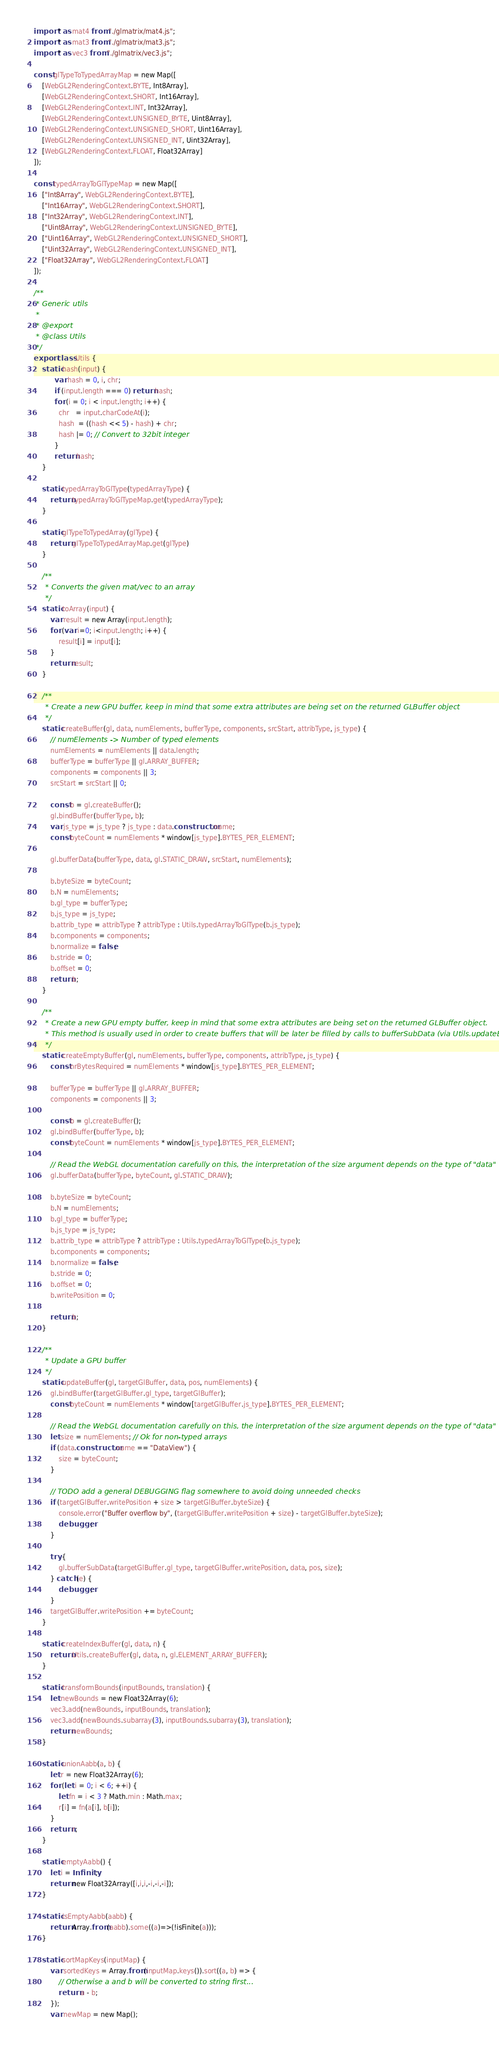<code> <loc_0><loc_0><loc_500><loc_500><_JavaScript_>import * as mat4 from "./glmatrix/mat4.js";
import * as mat3 from "./glmatrix/mat3.js";
import * as vec3 from "./glmatrix/vec3.js";

const glTypeToTypedArrayMap = new Map([
	[WebGL2RenderingContext.BYTE, Int8Array],
	[WebGL2RenderingContext.SHORT, Int16Array],
	[WebGL2RenderingContext.INT, Int32Array],
	[WebGL2RenderingContext.UNSIGNED_BYTE, Uint8Array],
	[WebGL2RenderingContext.UNSIGNED_SHORT, Uint16Array],
	[WebGL2RenderingContext.UNSIGNED_INT, Uint32Array],
	[WebGL2RenderingContext.FLOAT, Float32Array]
]);

const typedArrayToGlTypeMap = new Map([
	["Int8Array", WebGL2RenderingContext.BYTE],
	["Int16Array", WebGL2RenderingContext.SHORT],
	["Int32Array", WebGL2RenderingContext.INT],
	["Uint8Array", WebGL2RenderingContext.UNSIGNED_BYTE],
	["Uint16Array", WebGL2RenderingContext.UNSIGNED_SHORT],
	["Uint32Array", WebGL2RenderingContext.UNSIGNED_INT],
	["Float32Array", WebGL2RenderingContext.FLOAT]
]);

/**
 * Generic utils
 *
 * @export
 * @class Utils
 */
export class Utils {
	static hash(input) {
		  var hash = 0, i, chr;
		  if (input.length === 0) return hash;
		  for (i = 0; i < input.length; i++) {
		    chr   = input.charCodeAt(i);
		    hash  = ((hash << 5) - hash) + chr;
		    hash |= 0; // Convert to 32bit integer
		  }
		  return hash;
	}

	static typedArrayToGlType(typedArrayType) {
		return typedArrayToGlTypeMap.get(typedArrayType);
	}

	static glTypeToTypedArray(glType) {
		return glTypeToTypedArrayMap.get(glType)
	}
	
	/**
	 * Converts the given mat/vec to an array
	 */
	static toArray(input) {
		var result = new Array(input.length);
		for (var i=0; i<input.length; i++) {
			result[i] = input[i];
		}
		return result;
	}

	/**
	 * Create a new GPU buffer, keep in mind that some extra attributes are being set on the returned GLBuffer object
	 */
	static createBuffer(gl, data, numElements, bufferType, components, srcStart, attribType, js_type) {
		// numElements -> Number of typed elements
		numElements = numElements || data.length;
		bufferType = bufferType || gl.ARRAY_BUFFER;
		components = components || 3;
		srcStart = srcStart || 0;

		const b = gl.createBuffer();
		gl.bindBuffer(bufferType, b);
		var js_type = js_type ? js_type : data.constructor.name;
		const byteCount = numElements * window[js_type].BYTES_PER_ELEMENT;
		
		gl.bufferData(bufferType, data, gl.STATIC_DRAW, srcStart, numElements);
		
		b.byteSize = byteCount;
		b.N = numElements;
		b.gl_type = bufferType;
		b.js_type = js_type;
		b.attrib_type = attribType ? attribType : Utils.typedArrayToGlType(b.js_type);
		b.components = components;
		b.normalize = false;
		b.stride = 0;
		b.offset = 0;
		return b;
	}

	/**
	 * Create a new GPU empty buffer, keep in mind that some extra attributes are being set on the returned GLBuffer object.
	 * This method is usually used in order to create buffers that will be later be filled by calls to bufferSubData (via Utils.updateBuffer)
	 */
	static createEmptyBuffer(gl, numElements, bufferType, components, attribType, js_type) {
		const nrBytesRequired = numElements * window[js_type].BYTES_PER_ELEMENT;

		bufferType = bufferType || gl.ARRAY_BUFFER;
		components = components || 3;

		const b = gl.createBuffer();
		gl.bindBuffer(bufferType, b);
		const byteCount = numElements * window[js_type].BYTES_PER_ELEMENT;
		
		// Read the WebGL documentation carefully on this, the interpretation of the size argument depends on the type of "data"
		gl.bufferData(bufferType, byteCount, gl.STATIC_DRAW);
		
		b.byteSize = byteCount;
		b.N = numElements;
		b.gl_type = bufferType;
		b.js_type = js_type;
		b.attrib_type = attribType ? attribType : Utils.typedArrayToGlType(b.js_type);
		b.components = components;
		b.normalize = false;
		b.stride = 0;
		b.offset = 0;
		b.writePosition = 0;
		
		return b;
	}
	
	/**
	 * Update a GPU buffer
	 */	
	static updateBuffer(gl, targetGlBuffer, data, pos, numElements) {
		gl.bindBuffer(targetGlBuffer.gl_type, targetGlBuffer);
		const byteCount = numElements * window[targetGlBuffer.js_type].BYTES_PER_ELEMENT;
		
		// Read the WebGL documentation carefully on this, the interpretation of the size argument depends on the type of "data"
		let size = numElements; // Ok for non-typed arrays
		if (data.constructor.name == "DataView") {
			size = byteCount;
		}

		// TODO add a general DEBUGGING flag somewhere to avoid doing unneeded checks
		if (targetGlBuffer.writePosition + size > targetGlBuffer.byteSize) {
			console.error("Buffer overflow by", (targetGlBuffer.writePosition + size) - targetGlBuffer.byteSize);
			debugger;
		}
		
		try {
			gl.bufferSubData(targetGlBuffer.gl_type, targetGlBuffer.writePosition, data, pos, size);
		} catch (e) {
			debugger;
		}
		targetGlBuffer.writePosition += byteCount;
	}
	
	static createIndexBuffer(gl, data, n) {
		return Utils.createBuffer(gl, data, n, gl.ELEMENT_ARRAY_BUFFER);
	}

	static transformBounds(inputBounds, translation) {
		let newBounds = new Float32Array(6);
		vec3.add(newBounds, inputBounds, translation);
		vec3.add(newBounds.subarray(3), inputBounds.subarray(3), translation);
		return newBounds;
	}
	
	static unionAabb(a, b) {
		let r = new Float32Array(6);
		for (let i = 0; i < 6; ++i) {
			let fn = i < 3 ? Math.min : Math.max;
			r[i] = fn(a[i], b[i]);
		}
		return r;
	}

	static emptyAabb() {
		let i = Infinity;
		return new Float32Array([i,i,i,-i,-i,-i]);
	}

	static isEmptyAabb(aabb) {
		return Array.from(aabb).some((a)=>(!isFinite(a)));
	}
	
	static sortMapKeys(inputMap) {
		var sortedKeys = Array.from(inputMap.keys()).sort((a, b) => {
        	// Otherwise a and b will be converted to string first...
			return a - b;
		});
		var newMap = new Map();</code> 